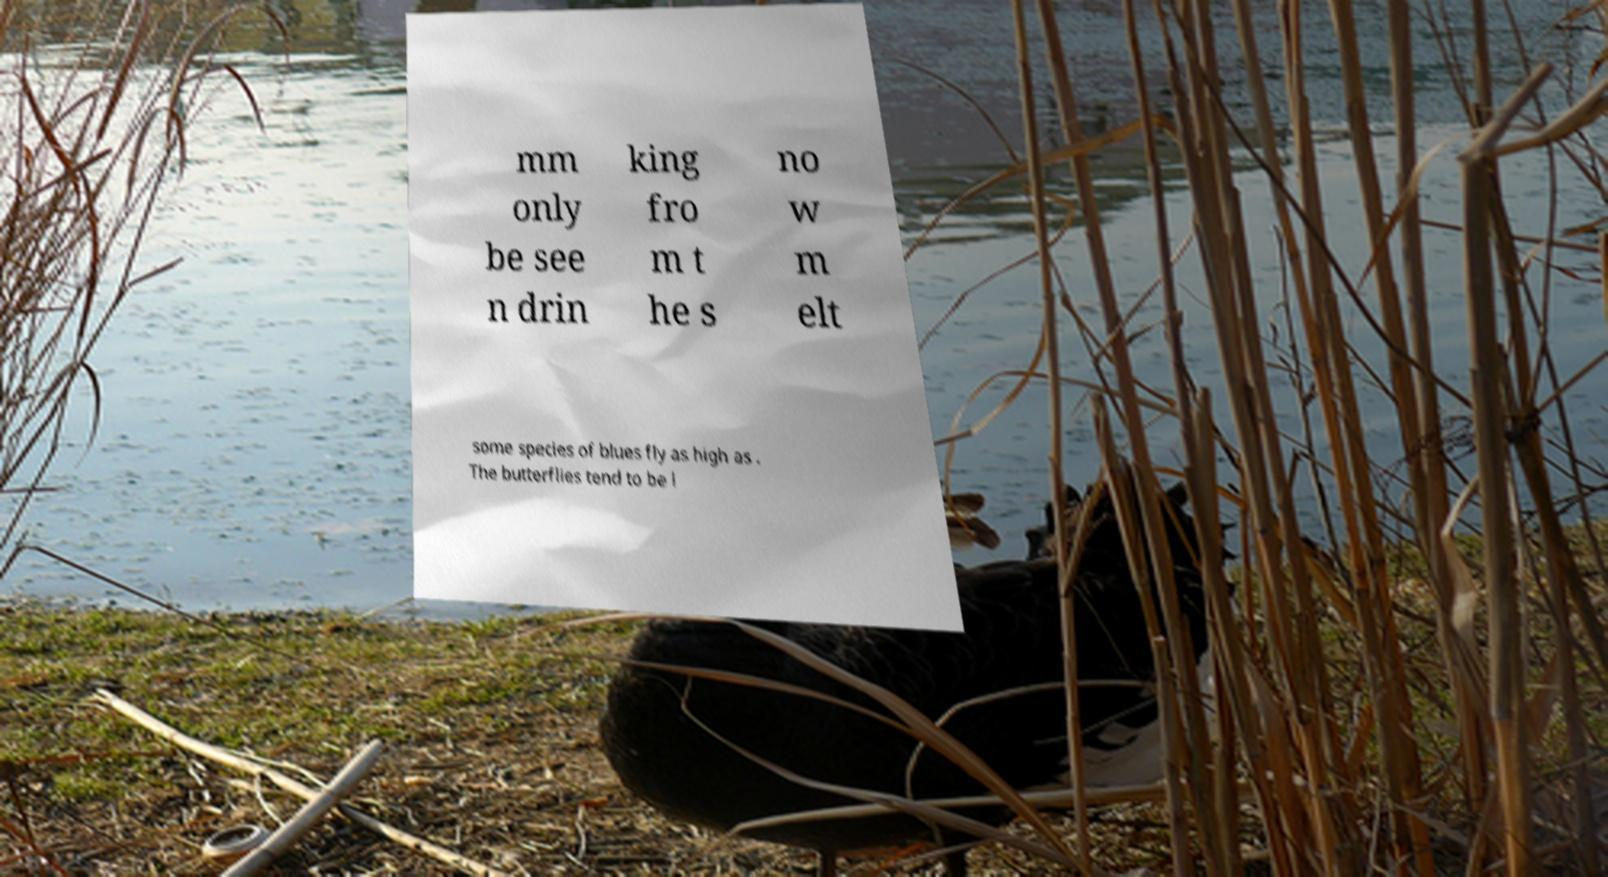For documentation purposes, I need the text within this image transcribed. Could you provide that? mm only be see n drin king fro m t he s no w m elt some species of blues fly as high as . The butterflies tend to be l 